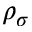<formula> <loc_0><loc_0><loc_500><loc_500>\rho _ { \sigma }</formula> 